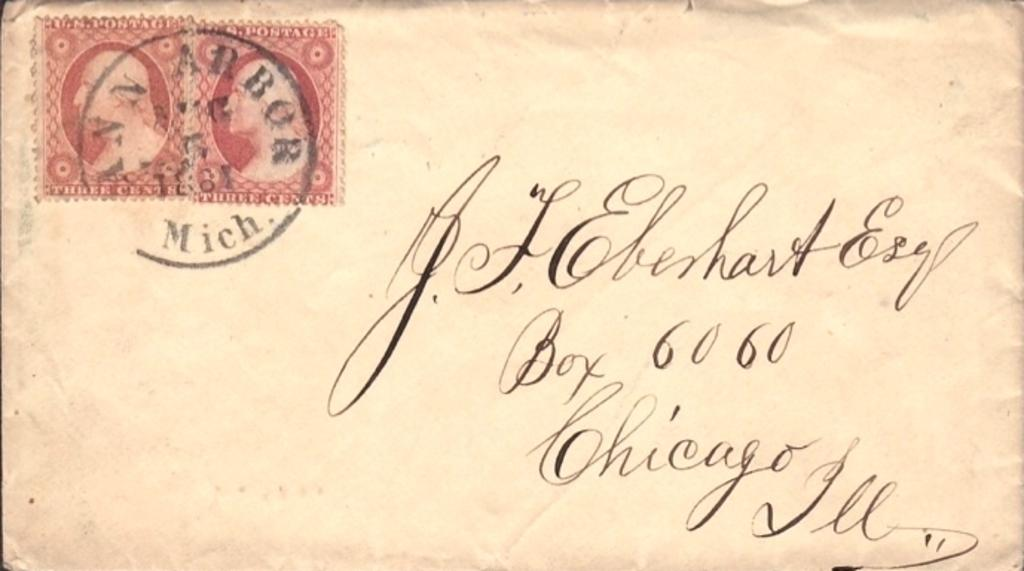Provide a one-sentence caption for the provided image. Old letter with cursive writing that is from Chicago. 